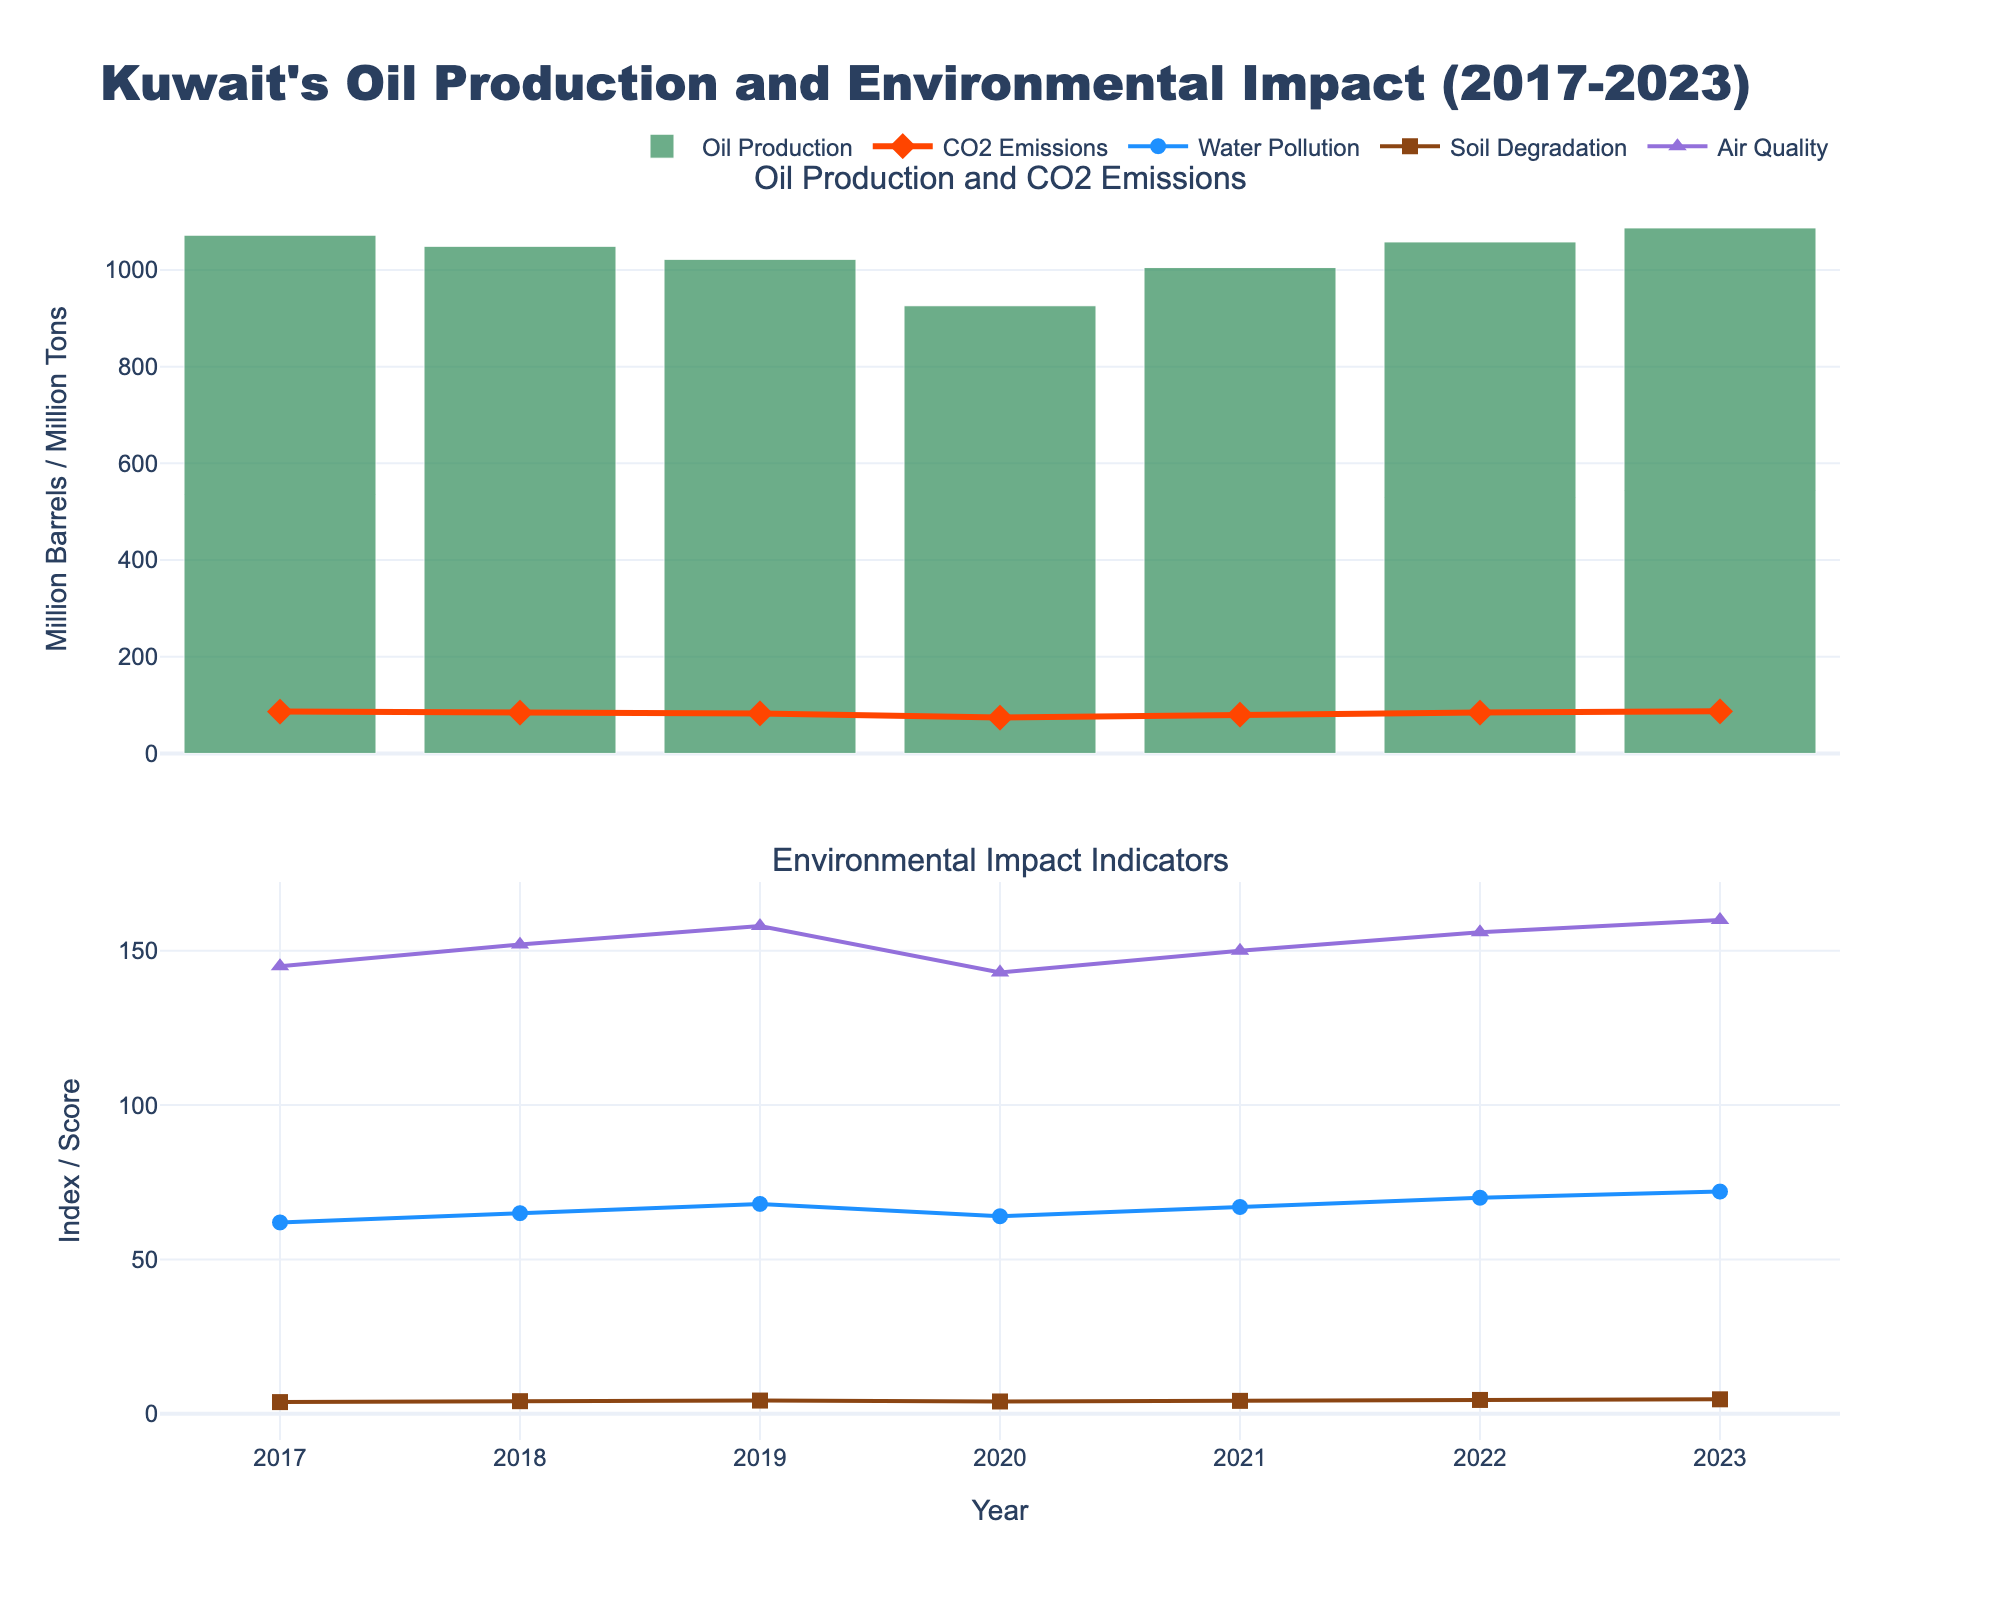What is the trend in oil production from 2017 to 2023? The oil production trend can be observed by examining the height of the green bars over the years. Starting in 2017, the production decreases until 2020, after which it increases again, reaching a peak in 2023.
Answer: Decreasing from 2017 to 2020, then increasing to 2023 Which year had the highest CO2 emissions, and how does it compare to the oil production of that year? The red line represents CO2 emissions and the highest point on this line is in 2023. The CO2 emissions in 2023 are 87.0 million tons, and the corresponding oil production (green bar) for that year is 1087 million barrels.
Answer: 2023; 87.0 million tons CO2 emissions, 1087 million barrels oil production How did the Air Quality Index change from 2020 to 2021, and what might this indicate? By looking at the purple line in the second subplot, the Air Quality Index decreases from 143 in 2020 to 150 in 2021, indicating an improvement in air quality during that period.
Answer: Increased from 143 to 150 Compare the Soil Degradation Score between 2018 and 2022. Which year had a higher score and by how much? The brown line in the second subplot shows the Soil Degradation Score. In 2018, the score is 4.1 and in 2022, it is 4.5. The score in 2022 is higher by 0.4.
Answer: 2022; higher by 0.4 What is the average Water Pollution Index from 2019 to 2023? The blue line in the second subplot shows the Water Pollution Index. For the years 2019 to 2023, the values are: 68, 64, 67, 70, and 72. The average is calculated as (68 + 64 + 67 + 70 + 72) / 5 = 68.2.
Answer: 68.2 Is there a correlation between oil production and CO2 emissions from 2017 to 2023? To check for correlation, observe the trend of green bars (oil production) and the red line (CO2 emissions). Both show a similar trend of decreasing from 2017 to 2020 and then increasing until 2023, suggesting a positive correlation.
Answer: Positive correlation Which indicator shows the most significant negative trend over the observed years, and what does this signify about environmental conditions? By comparing the lines from the second subplot, the Air Quality Index (purple line) shows the most significant negative trend, indicating that air quality has been worsening over the years.
Answer: Air Quality Index, worsening air quality What was the change in Water Pollution Index from 2020 to 2022, and what does that imply? The blue line for the Water Pollution Index shows values of 64 in 2020 and 70 in 2022. The index increased by 6 points, indicating worsening water pollution.
Answer: Increase by 6 points, worsening water pollution Between 2020 and 2021, which year had better environmental indicators overall, and why? Analyzing the indicators in the second subplot: Water Pollution Index (64 to 67), Soil Degradation Score (4.0 to 4.2), and Air Quality Index (143 to 150). Environmental conditions worsened in 2021 due to increases in all respective indexes.
Answer: 2020; better environmental indicators How does the Air Quality Index in 2023 compare to the overall average from 2017 to 2023? Calculate the overall average from 2017 to 2023: (145+152+158+143+150+156+160)/7 = 152. The Air Quality Index in 2023 is 160, which is higher than the overall average.
Answer: 160; higher than 152 